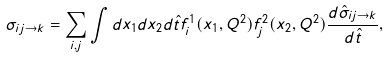Convert formula to latex. <formula><loc_0><loc_0><loc_500><loc_500>\sigma _ { i j \rightarrow k } = \sum _ { i , j } \int d x _ { 1 } d x _ { 2 } d { \hat { t } } f _ { i } ^ { 1 } ( x _ { 1 } , Q ^ { 2 } ) f _ { j } ^ { 2 } ( x _ { 2 } , Q ^ { 2 } ) { \frac { d { \hat { \sigma } } _ { i j \rightarrow k } } { d { \hat { t } } } } ,</formula> 